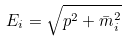Convert formula to latex. <formula><loc_0><loc_0><loc_500><loc_500>E _ { i } = \sqrt { p ^ { 2 } + \bar { m } _ { i } ^ { 2 } }</formula> 